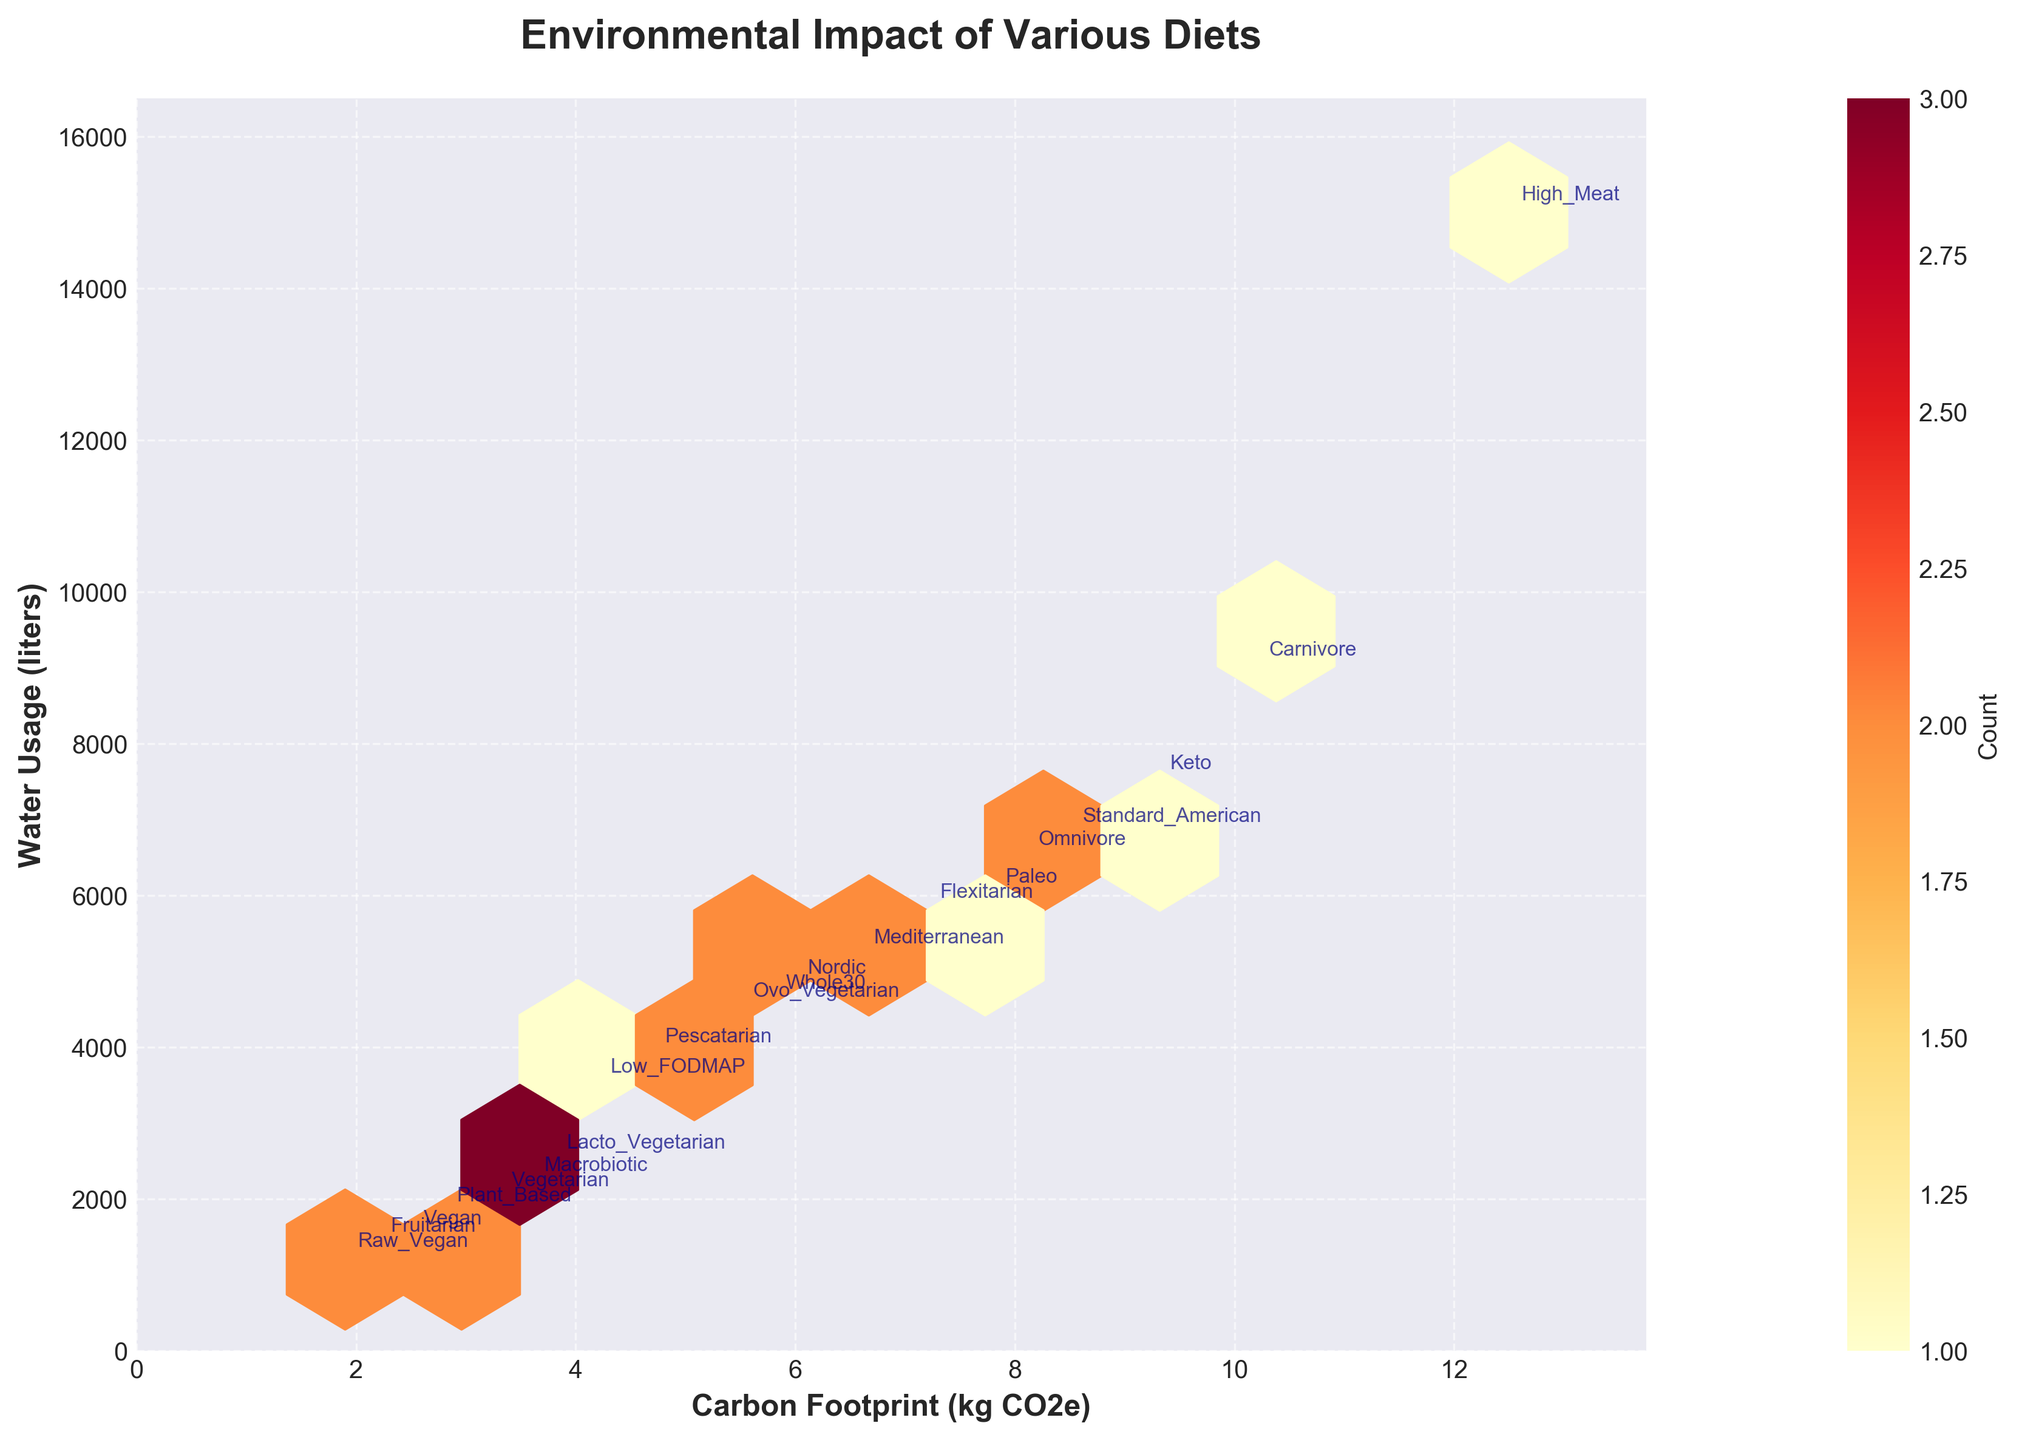What does the title of the plot indicate? The title of the plot is "Environmental Impact of Various Diets", which indicates that the plot is showing the environmental effects, specifically carbon footprint and water usage, of different diet choices.
Answer: Environmental Impact of Various Diets What are the labels of the x and y axes? The x-axis is labeled "Carbon Footprint (kg CO2e)" and the y-axis is labeled "Water Usage (liters)".
Answer: Carbon Footprint (kg CO2e), Water Usage (liters) How many diets are represented in the plot? The plot represents 20 different diet categories.
Answer: 20 Which diet has the highest carbon footprint? The diet with the highest carbon footprint is "High_Meat" as indicated by the far right data point.
Answer: High_Meat Which diet uses the least amount of water? The diet with the least amount of water usage is "Raw_Vegan" as indicated by the lowest data point on the y-axis.
Answer: Raw_Vegan Which diets have a carbon footprint lower than 5 kg CO2e? Diets with a carbon footprint lower than 5 kg CO2e are "Vegan", "Vegetarian", "Raw_Vegan", "Plant_Based", "Macrobiotic", "Lacto_Vegetarian", "Fruitarian".
Answer: Vegan, Vegetarian, Raw_Vegan, Plant_Based, Macrobiotic, Lacto_Vegetarian, Fruitarian Between "Mediterranean" and "Keto" diets, which one has a higher water usage? "Keto" has a higher water usage than "Mediterranean" as it is located higher on the y-axis.
Answer: Keto What's the average water usage for diets with a carbon footprint between 6 and 8 kg CO2e? The diets in this range are Mediterranean, Flexitarian, Ovo_Vegetarian, and Paleo. Their water usages are 5200, 5800, 4500, and 6000 liters respectively. The average is (5200+5800+4500+6000)/4 = 5375 liters.
Answer: 5375 liters Which diet has a high water usage but a low carbon footprint compared to others? "Raw_Vegan" diet has one of the lowest carbon footprints but has a relatively high water usage.
Answer: Raw_Vegan What is the relationship between carbon footprint and water usage in the plot? Generally, there is a positive correlation between carbon footprint and water usage; as one increases, the other also tends to increase.
Answer: Positive correlation 